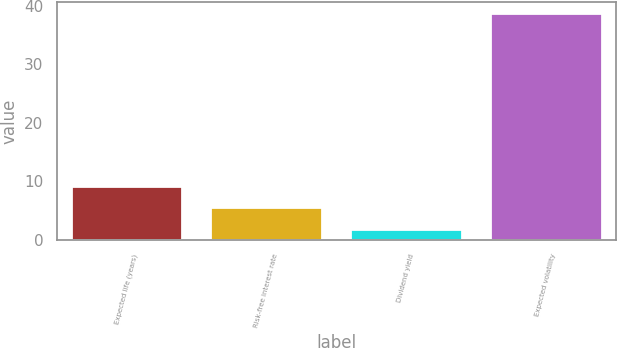<chart> <loc_0><loc_0><loc_500><loc_500><bar_chart><fcel>Expected life (years)<fcel>Risk-free interest rate<fcel>Dividend yield<fcel>Expected volatility<nl><fcel>9.26<fcel>5.58<fcel>1.9<fcel>38.7<nl></chart> 